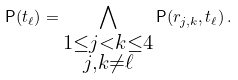Convert formula to latex. <formula><loc_0><loc_0><loc_500><loc_500>\mathsf P ( t _ { \ell } ) = \bigwedge _ { \substack { 1 \leq j < k \leq 4 \\ j , k \neq \ell } } \mathsf P ( r _ { j , k } , t _ { \ell } ) \, .</formula> 